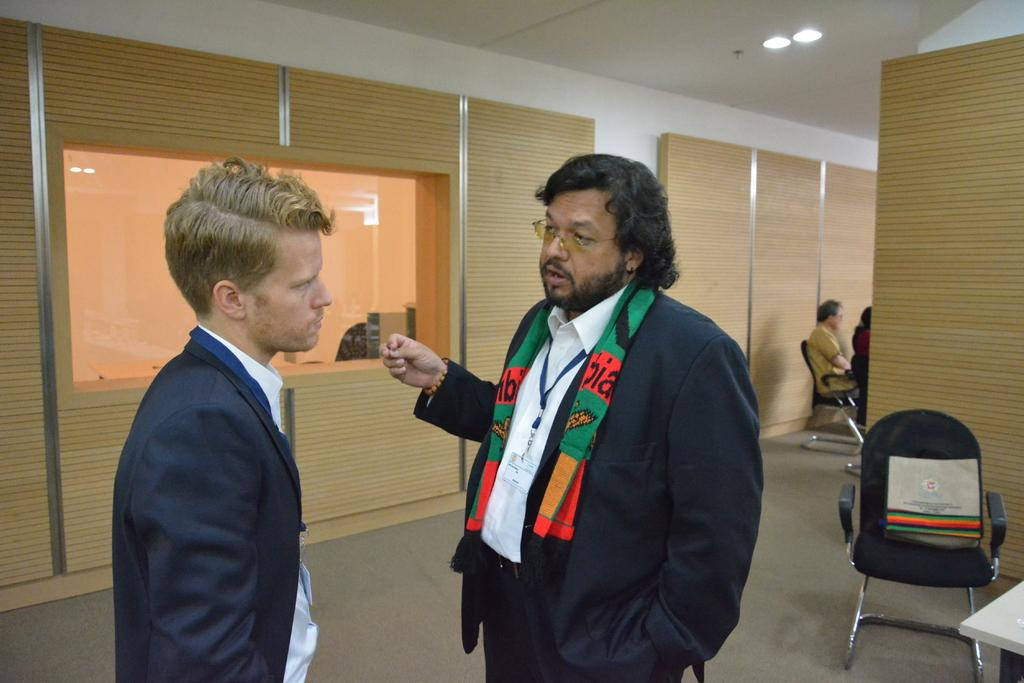How many people are in the image? There are two persons in the image. What are the two persons wearing? Both persons are wearing black blazers. What are the two persons doing in the image? The two persons are standing and looking at each other. What can be seen in the background of the image? There is a chair, a bag, and a wall in the background of the image. Absurd Question/Answer: What type of playground equipment can be seen in the image? There is no playground equipment present in the image. What day of the week is depicted in the image? The image does not show a specific day of the week. What type of pen is being used by the person in the image? There is no pen present in the image. 